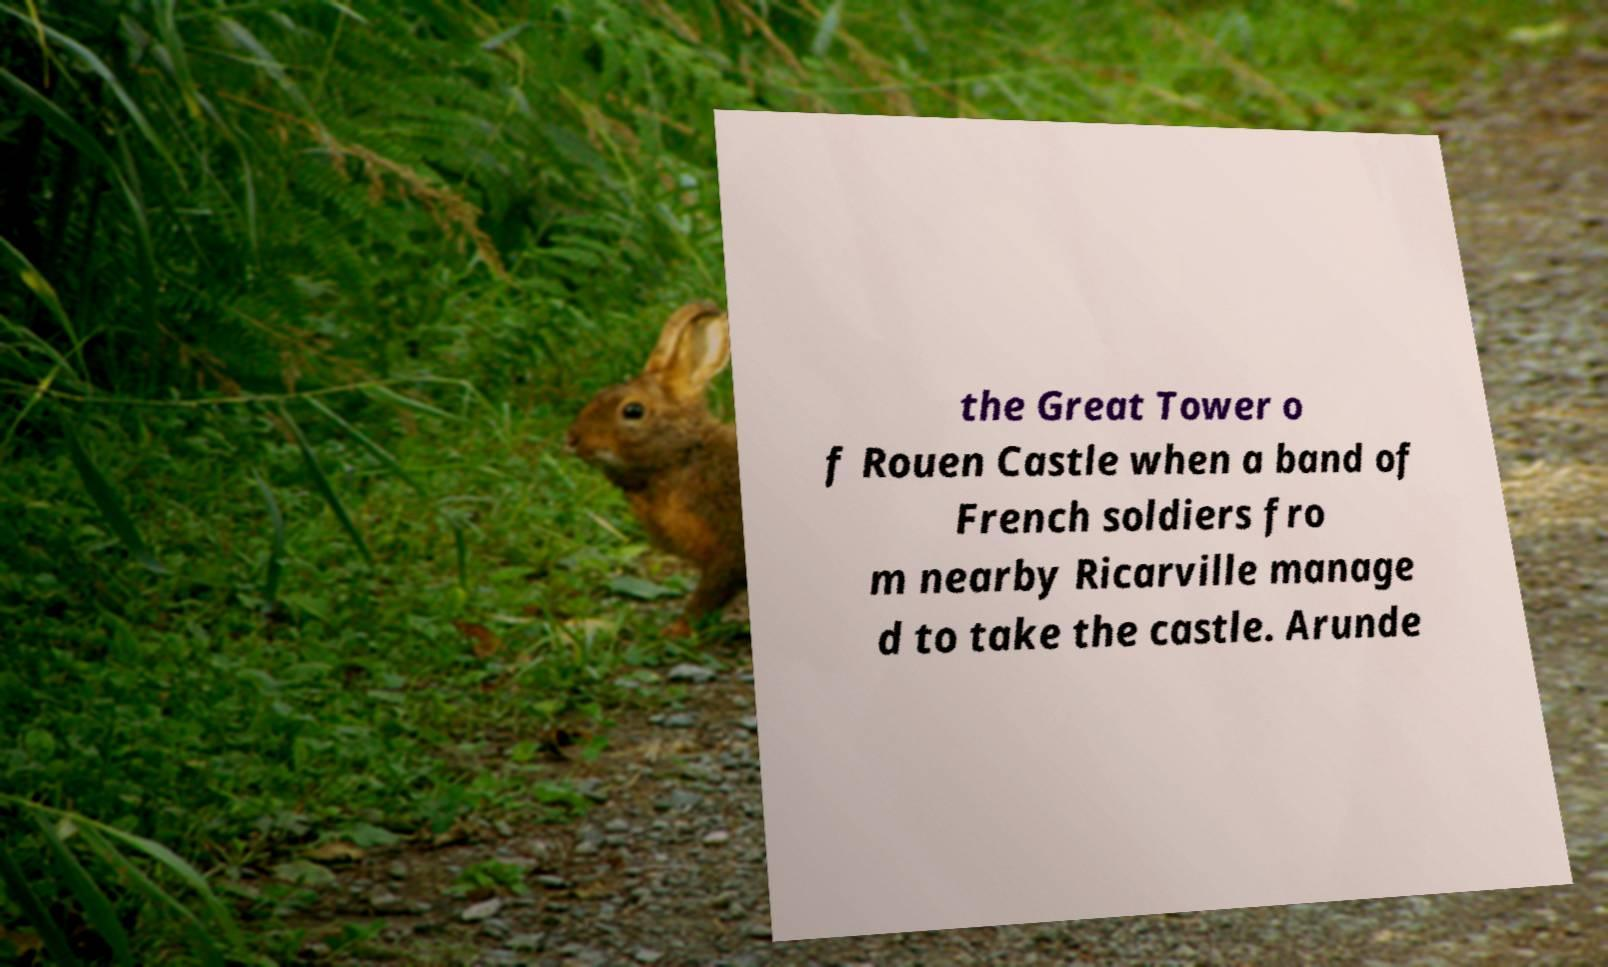There's text embedded in this image that I need extracted. Can you transcribe it verbatim? the Great Tower o f Rouen Castle when a band of French soldiers fro m nearby Ricarville manage d to take the castle. Arunde 